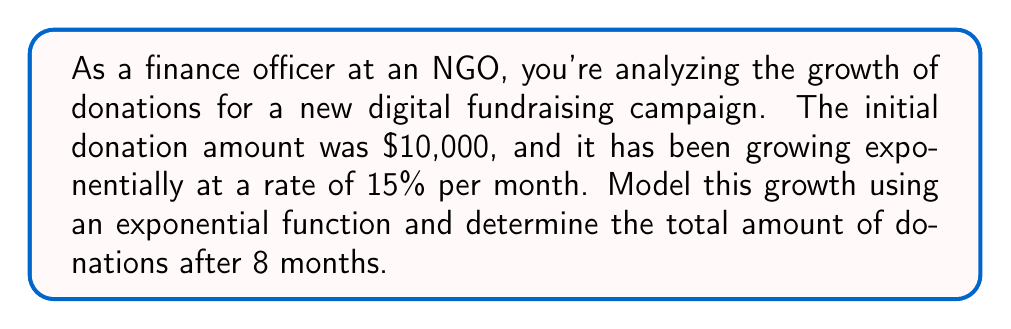Teach me how to tackle this problem. To model the donation growth using an exponential function, we'll use the general form:

$$A(t) = A_0 \cdot (1 + r)^t$$

Where:
$A(t)$ is the amount after time $t$
$A_0$ is the initial amount
$r$ is the growth rate (as a decimal)
$t$ is the time period

Given:
$A_0 = \$10,000$ (initial donation)
$r = 0.15$ (15% growth rate)
$t = 8$ months

Let's substitute these values into our exponential function:

$$A(8) = 10000 \cdot (1 + 0.15)^8$$

Now, let's calculate:

$$A(8) = 10000 \cdot (1.15)^8$$
$$A(8) = 10000 \cdot 3.0590$$
$$A(8) = 30,590$$

Therefore, after 8 months, the total amount of donations will be $30,590.
Answer: $30,590 